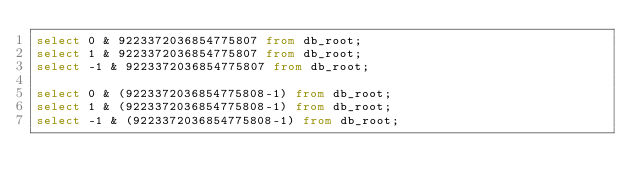<code> <loc_0><loc_0><loc_500><loc_500><_SQL_>select 0 & 9223372036854775807 from db_root;
select 1 & 9223372036854775807 from db_root;
select -1 & 9223372036854775807 from db_root;

select 0 & (9223372036854775808-1) from db_root;
select 1 & (9223372036854775808-1) from db_root;
select -1 & (9223372036854775808-1) from db_root;
</code> 